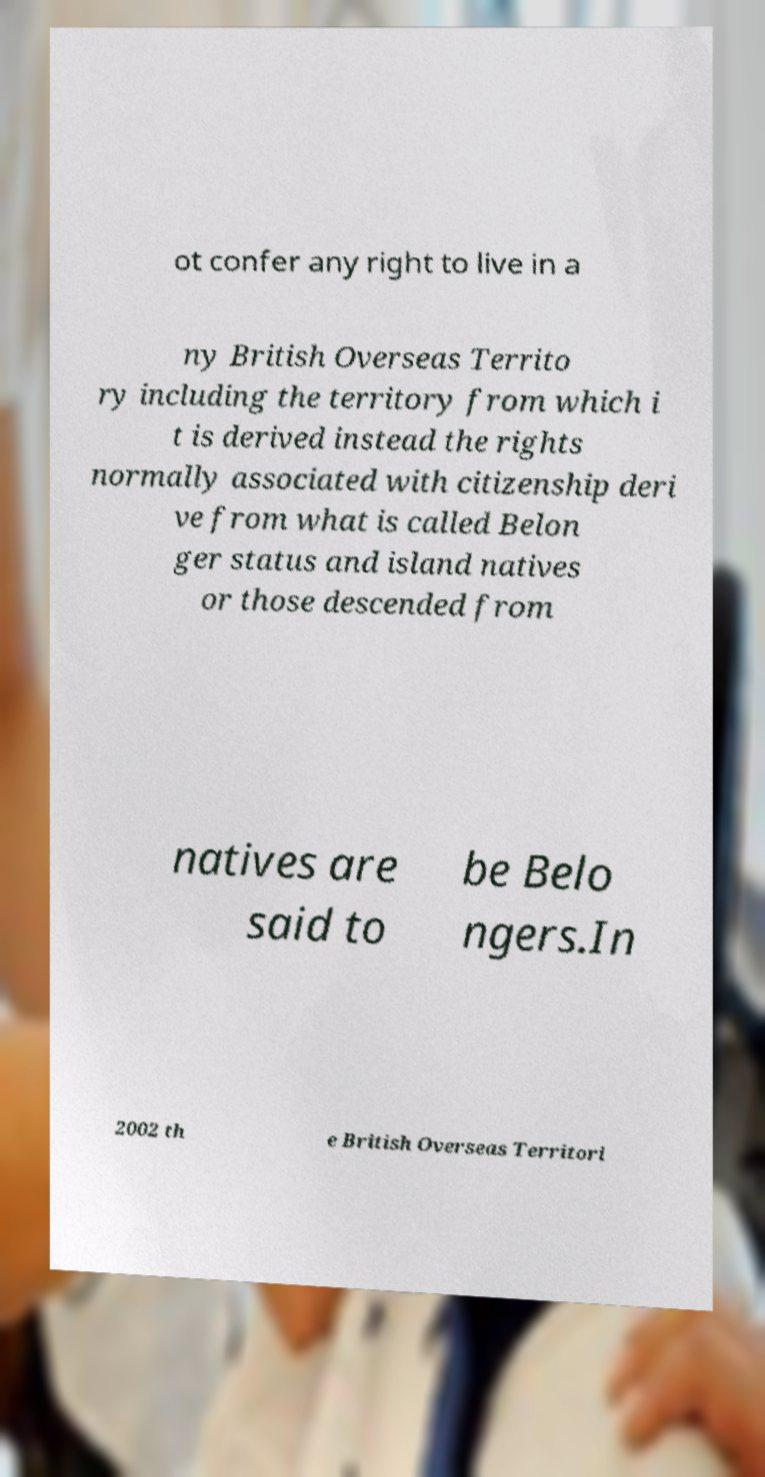There's text embedded in this image that I need extracted. Can you transcribe it verbatim? ot confer any right to live in a ny British Overseas Territo ry including the territory from which i t is derived instead the rights normally associated with citizenship deri ve from what is called Belon ger status and island natives or those descended from natives are said to be Belo ngers.In 2002 th e British Overseas Territori 